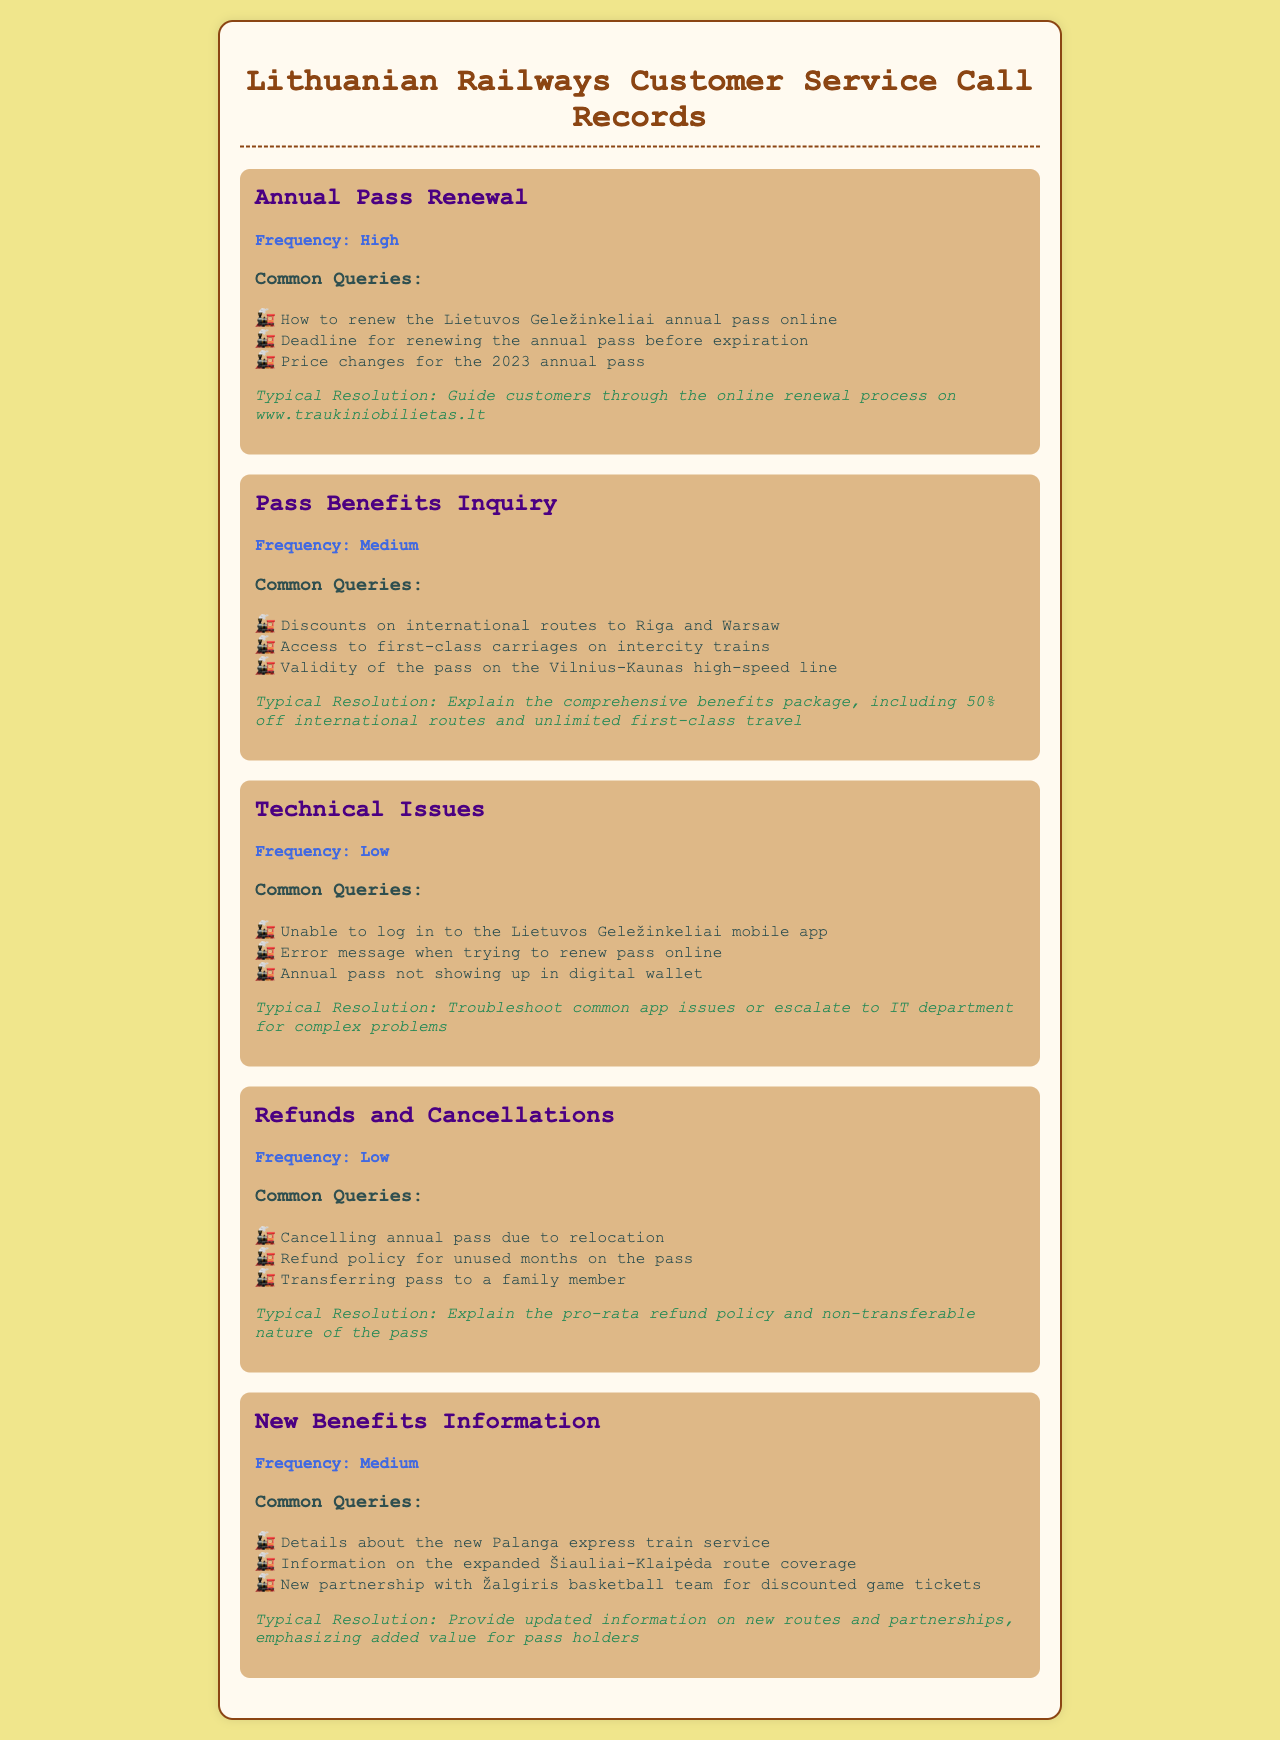What is the frequency of calls regarding Annual Pass Renewal? The frequency of calls regarding Annual Pass Renewal is categorized as high in the document.
Answer: High How many common queries are listed under Pass Benefits Inquiry? There are three common queries mentioned under Pass Benefits Inquiry in the document.
Answer: 3 What is the typical resolution for technical issues? The typical resolution for technical issues involves troubleshooting common app issues or escalating to the IT department for complex problems.
Answer: Troubleshoot or escalate What details are provided about discounts for international routes? The document specifies that there are 50% off discounts on international routes to Riga and Warsaw.
Answer: 50% off How many common queries are listed under Refunds and Cancellations? There are three common queries mentioned under Refunds and Cancellations.
Answer: 3 What type of document is this text? The text is a record of customer service calls related to Lithuanian Railways, focusing on annual train passes.
Answer: Telephone records What is the frequency of calls regarding New Benefits Information? The frequency of calls regarding New Benefits Information is classified as medium.
Answer: Medium What are the two main reasons people call regarding Refunds and Cancellations? Common queries include cancelling due to relocation and the refund policy for unused months.
Answer: Relocation and refund policy 